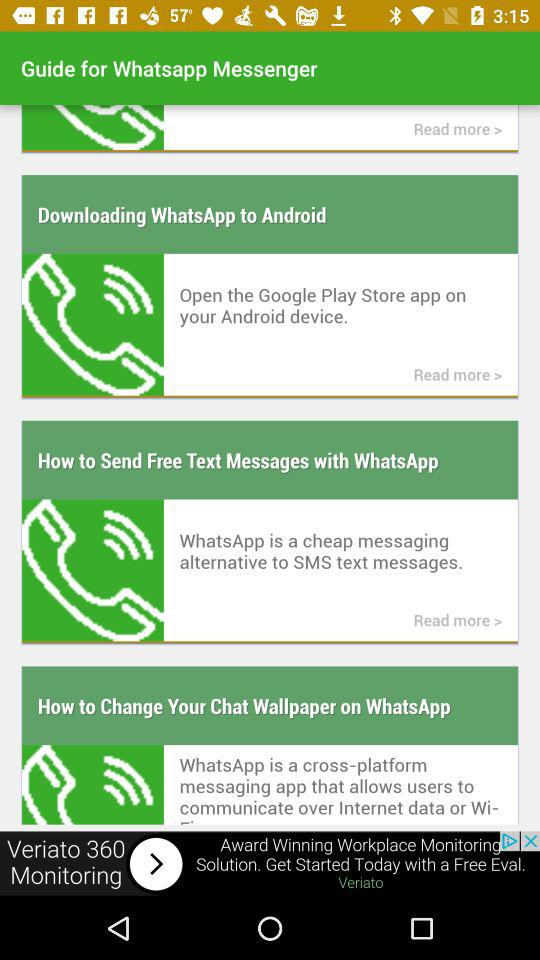What are the steps to change the chat wallpaper?
When the provided information is insufficient, respond with <no answer>. <no answer> 